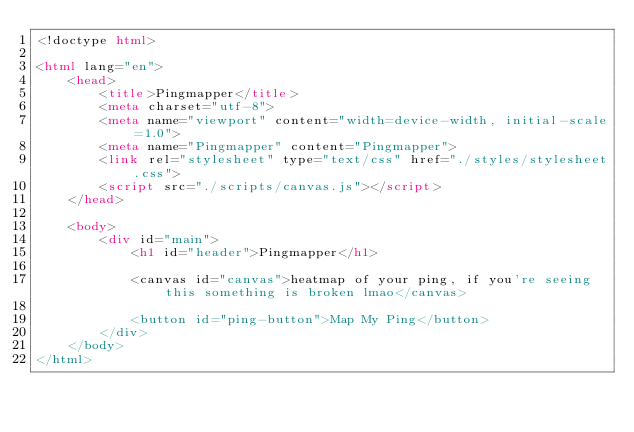Convert code to text. <code><loc_0><loc_0><loc_500><loc_500><_HTML_><!doctype html>

<html lang="en">
    <head>
        <title>Pingmapper</title>
        <meta charset="utf-8">
        <meta name="viewport" content="width=device-width, initial-scale=1.0">
        <meta name="Pingmapper" content="Pingmapper">
        <link rel="stylesheet" type="text/css" href="./styles/stylesheet.css">
        <script src="./scripts/canvas.js"></script>
    </head>

    <body>
        <div id="main">
            <h1 id="header">Pingmapper</h1>

            <canvas id="canvas">heatmap of your ping, if you're seeing this something is broken lmao</canvas>

            <button id="ping-button">Map My Ping</button>
        </div>
    </body>
</html></code> 